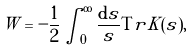Convert formula to latex. <formula><loc_0><loc_0><loc_500><loc_500>W = - \frac { 1 } { 2 } \int ^ { \infty } _ { 0 } \frac { { \mathrm d } s } { s } { \mathrm T r } K ( s ) ,</formula> 